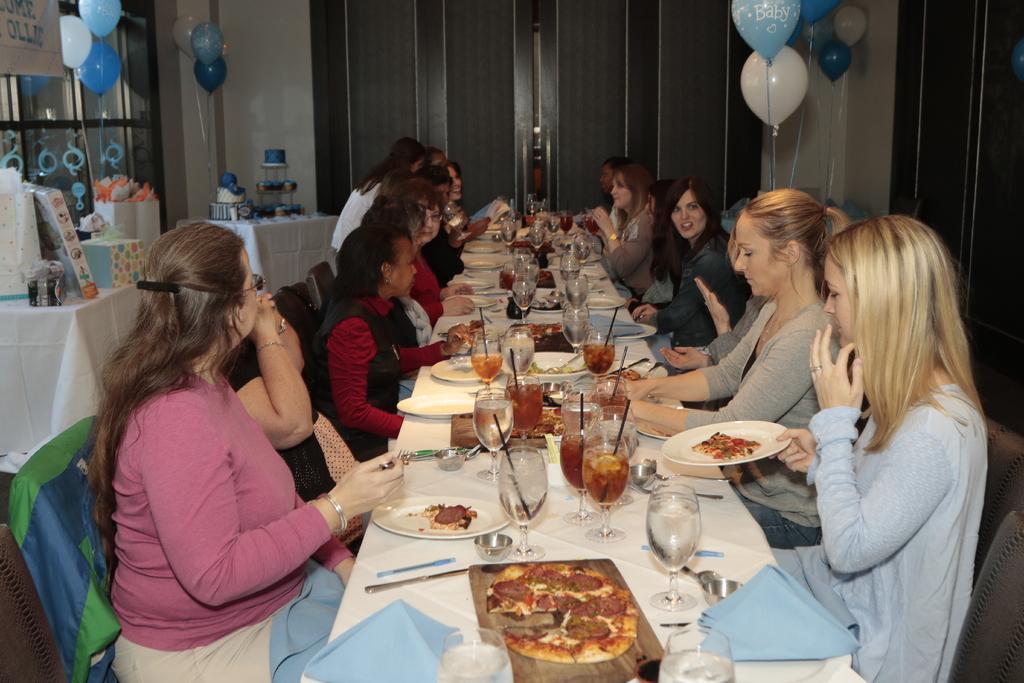In one or two sentences, can you explain what this image depicts? This is a picture in a restaurant. In the center of the picture there is a table covered with cloth, on the table there are plates glasses, drinks, spoons, kerchiefs, and various food items. Around the table there are many women seated. On the top right and top left there are balloons. In the center of the background there is a door. On the left the tables, on the table there are gifts and cakes. 